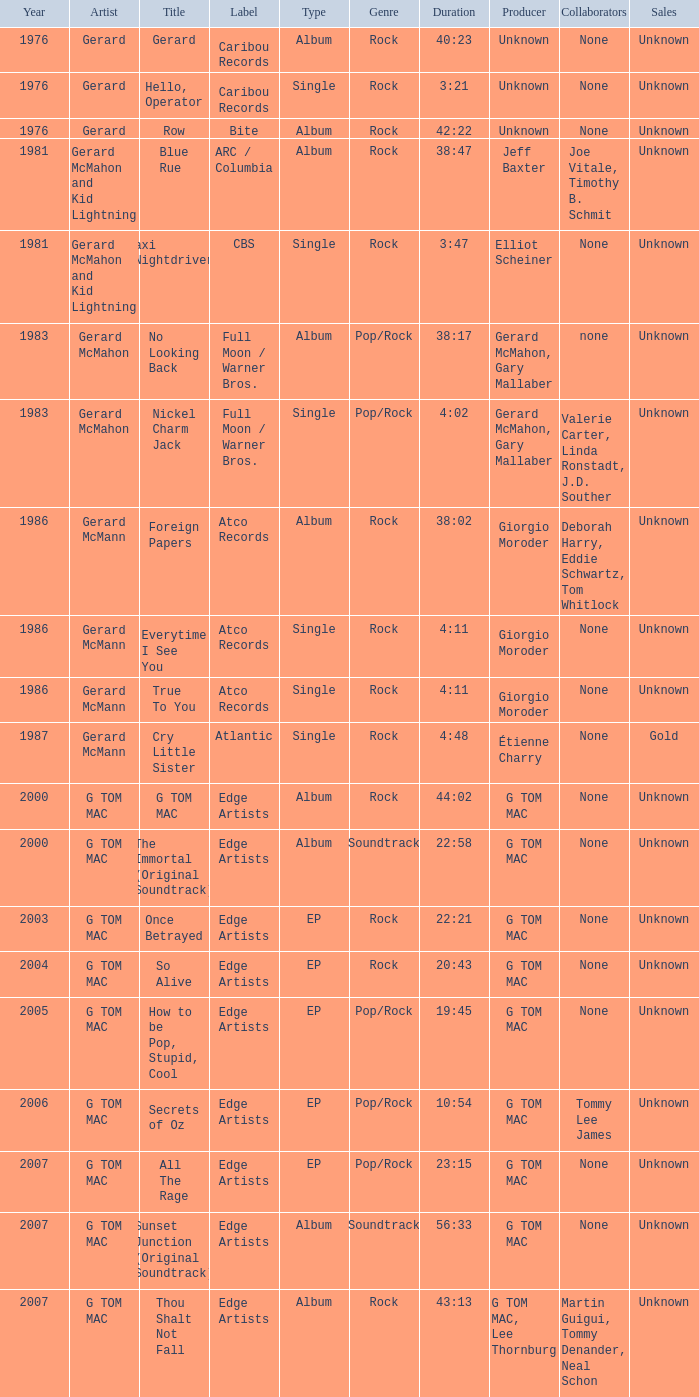Which type has a title of so alive? EP. 